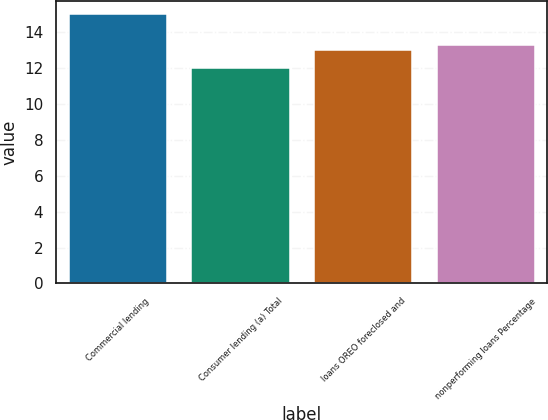<chart> <loc_0><loc_0><loc_500><loc_500><bar_chart><fcel>Commercial lending<fcel>Consumer lending (a) Total<fcel>loans OREO foreclosed and<fcel>nonperforming loans Percentage<nl><fcel>15<fcel>12<fcel>13<fcel>13.3<nl></chart> 